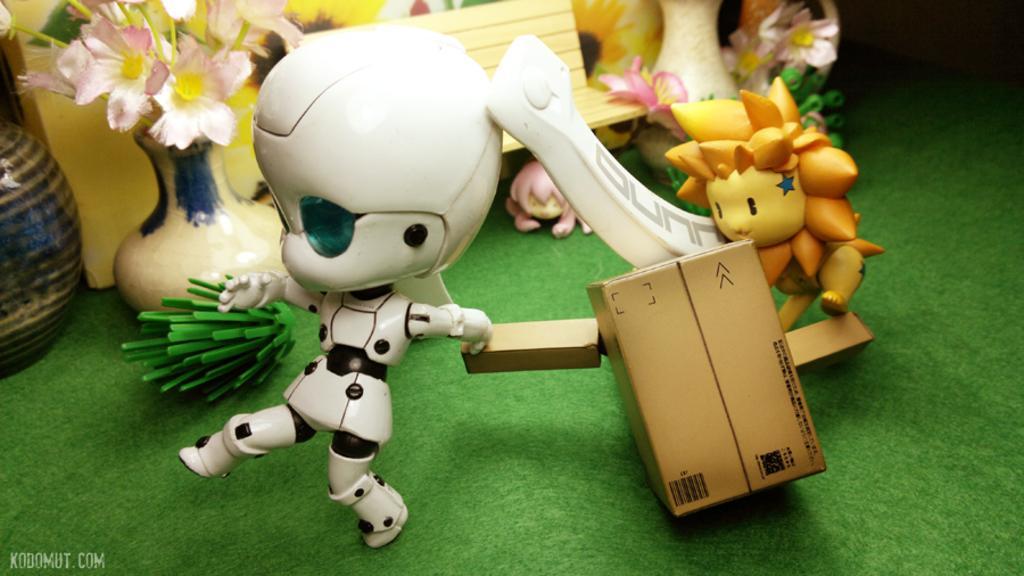In one or two sentences, can you explain what this image depicts? In this image, we can see some toys and flower vases. 